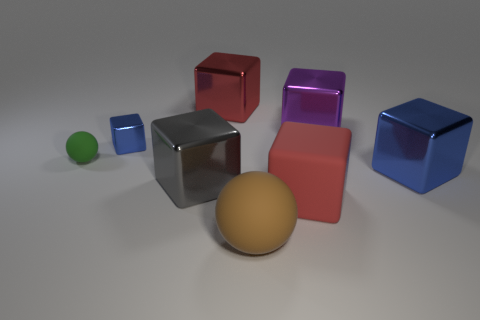Subtract all large red matte cubes. How many cubes are left? 5 Subtract all purple blocks. How many blocks are left? 5 Subtract all brown cubes. Subtract all green balls. How many cubes are left? 6 Add 1 gray cubes. How many objects exist? 9 Subtract all spheres. How many objects are left? 6 Subtract all purple shiny things. Subtract all blocks. How many objects are left? 1 Add 4 big red matte cubes. How many big red matte cubes are left? 5 Add 4 green matte cylinders. How many green matte cylinders exist? 4 Subtract 0 red cylinders. How many objects are left? 8 